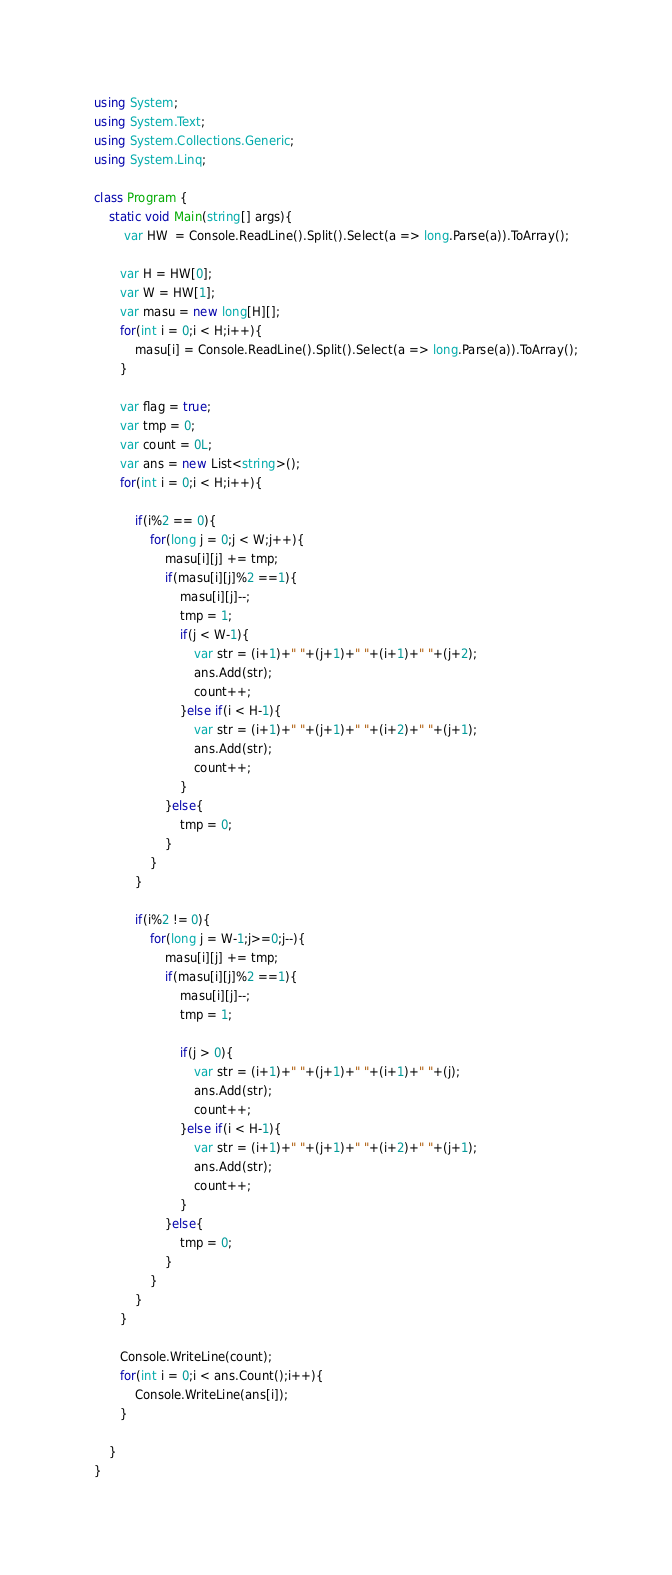Convert code to text. <code><loc_0><loc_0><loc_500><loc_500><_C#_>using System;
using System.Text;
using System.Collections.Generic;
using System.Linq;
 
class Program {
    static void Main(string[] args){
        var HW  = Console.ReadLine().Split().Select(a => long.Parse(a)).ToArray();
        
       var H = HW[0];
       var W = HW[1];
       var masu = new long[H][];
       for(int i = 0;i < H;i++){
           masu[i] = Console.ReadLine().Split().Select(a => long.Parse(a)).ToArray();
       }
       
       var flag = true;
       var tmp = 0;
       var count = 0L;
       var ans = new List<string>();
       for(int i = 0;i < H;i++){
           
           if(i%2 == 0){
               for(long j = 0;j < W;j++){
                   masu[i][j] += tmp;
                   if(masu[i][j]%2 ==1){
                       masu[i][j]--;
                       tmp = 1;
                       if(j < W-1){
                           var str = (i+1)+" "+(j+1)+" "+(i+1)+" "+(j+2);
                           ans.Add(str);
                           count++;
                       }else if(i < H-1){
                           var str = (i+1)+" "+(j+1)+" "+(i+2)+" "+(j+1);
                           ans.Add(str);
                           count++;
                       }
                   }else{
                       tmp = 0;
                   }
               }
           }
           
           if(i%2 != 0){
               for(long j = W-1;j>=0;j--){
                   masu[i][j] += tmp;
                   if(masu[i][j]%2 ==1){
                       masu[i][j]--;
                       tmp = 1;
                       
                       if(j > 0){
                           var str = (i+1)+" "+(j+1)+" "+(i+1)+" "+(j);
                           ans.Add(str);
                           count++;
                       }else if(i < H-1){
                           var str = (i+1)+" "+(j+1)+" "+(i+2)+" "+(j+1);
                           ans.Add(str);
                           count++;
                       }
                   }else{
                       tmp = 0;
                   }
               }
           }
       }
       
       Console.WriteLine(count);
       for(int i = 0;i < ans.Count();i++){
           Console.WriteLine(ans[i]);
       }
       
    }      
}
</code> 